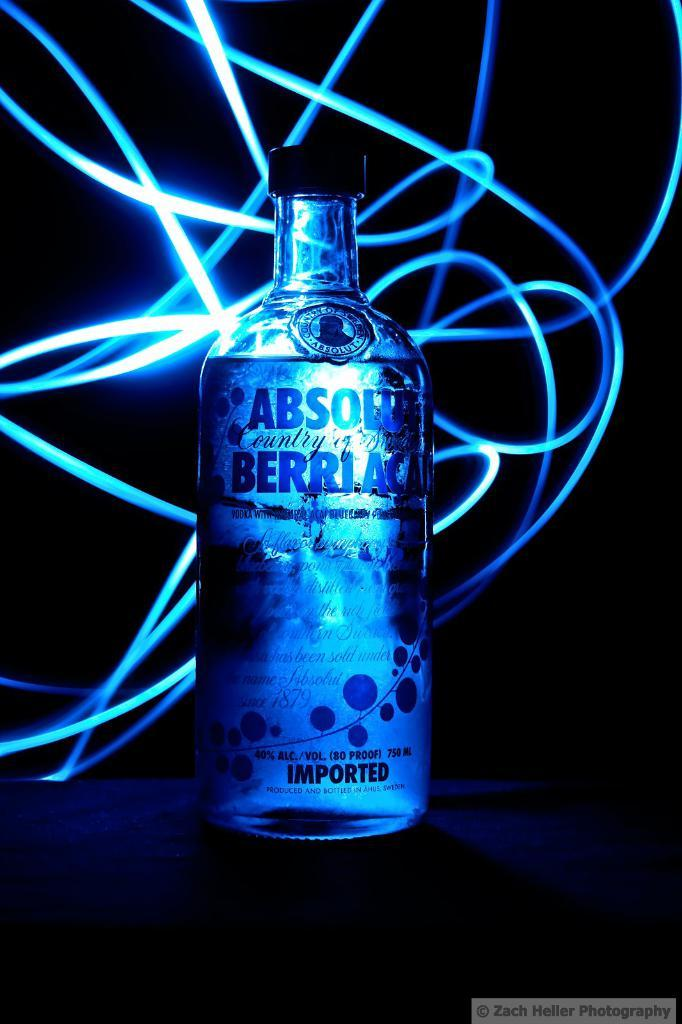<image>
Present a compact description of the photo's key features. A bottle of Absolut Berrlac sitting in the dark with various neon rope lights behind it. 